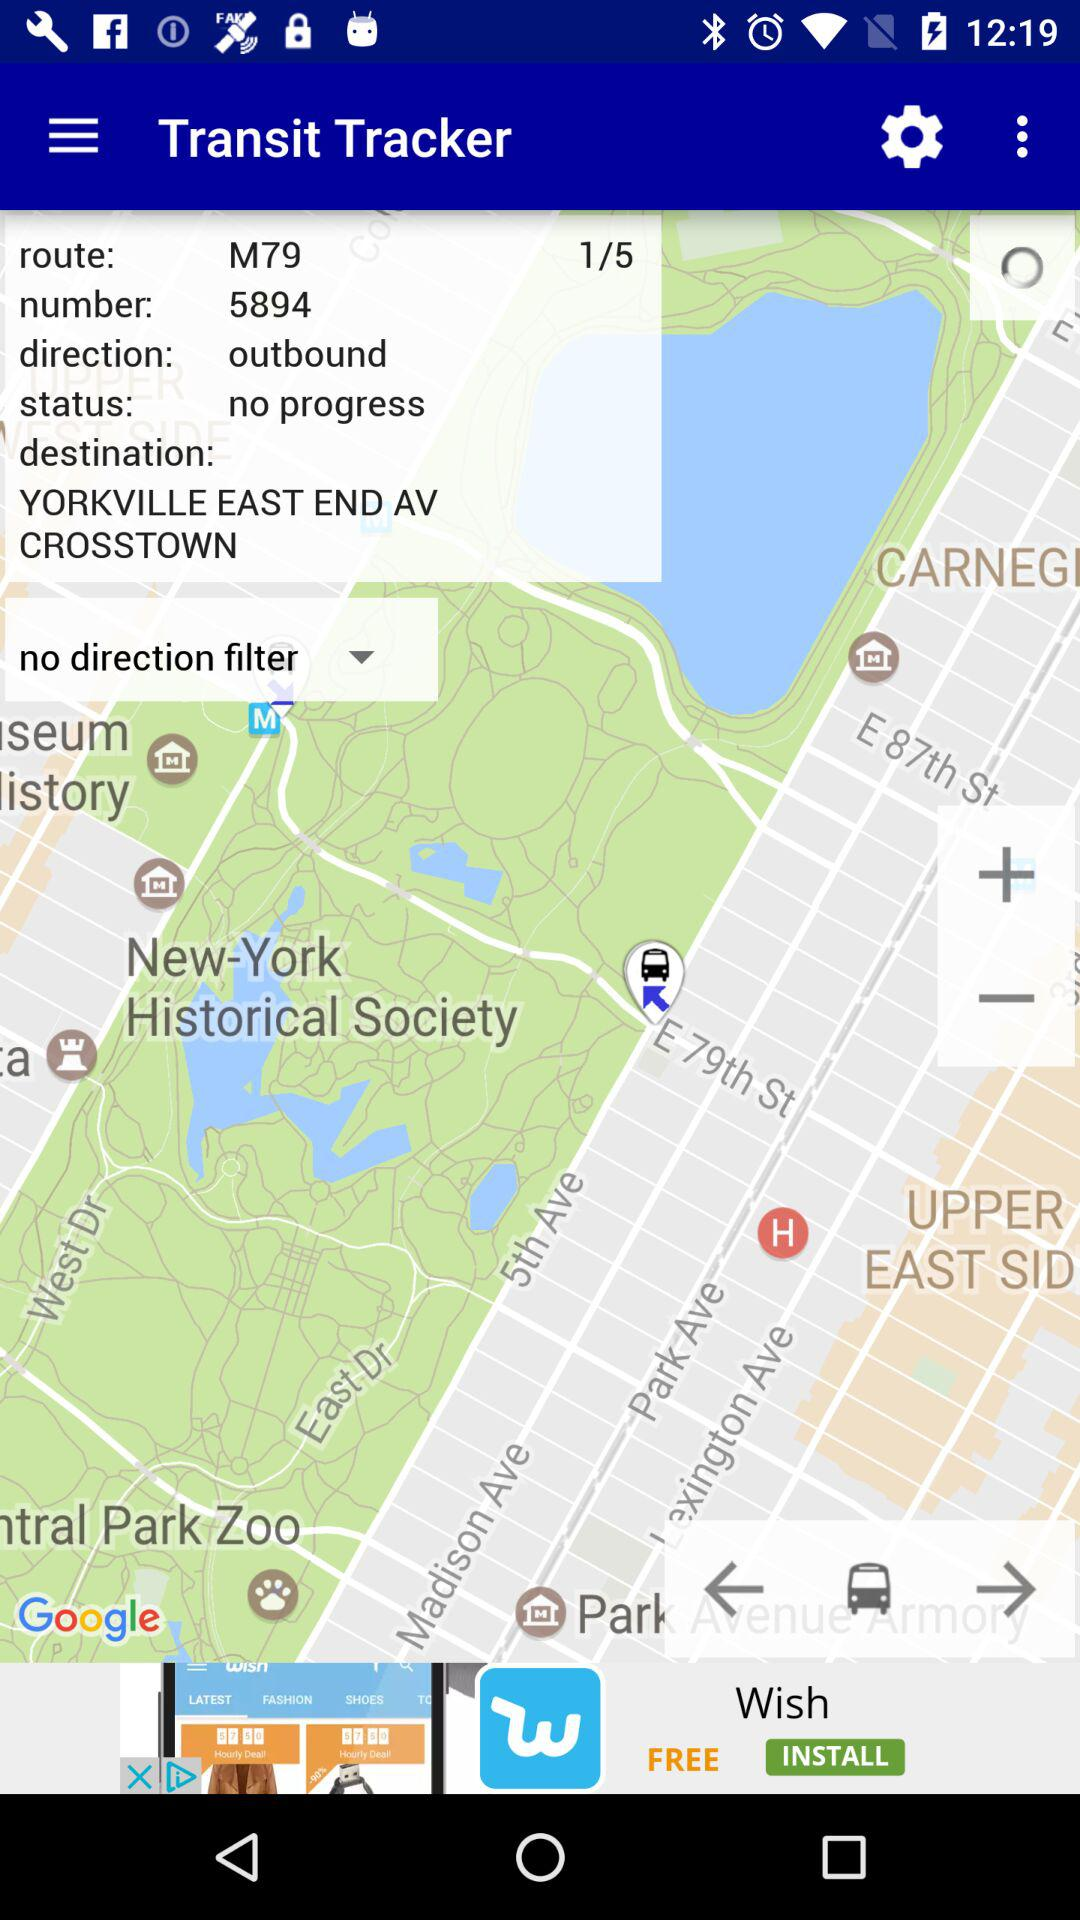What is the destination? The destination is Yorkville, East End Avenue, Crosstown. 